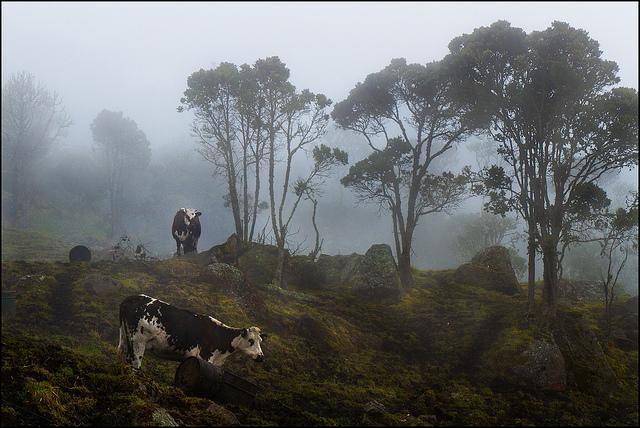Is this animal from Europe?
Be succinct. No. What sort of food are the cows eating?
Write a very short answer. Grass. What is the weather like?
Write a very short answer. Foggy. Are the animals in a compound?
Keep it brief. No. Is this a big city?
Concise answer only. No. Is it a cloudy day?
Short answer required. Yes. Is it a sunny day?
Give a very brief answer. No. What animal is in the photo?
Short answer required. Cow. Is the sun shining on the animals?
Answer briefly. No. What animal is this?
Quick response, please. Cow. Was this picture taken in the city?
Concise answer only. No. Why is it so dark outside?
Keep it brief. Fog. Is this a sheep and a cat?
Short answer required. No. What animals are shown in the photo?
Write a very short answer. Cows. Do these two like each other?
Write a very short answer. No. Where could you find this animal?
Keep it brief. Farm. Is there a calf with this cow?
Keep it brief. No. Are the animals wild?
Concise answer only. No. Are those brown spots?
Be succinct. Yes. Is it springtime?
Answer briefly. Yes. What is this animal?
Answer briefly. Cow. Are these animals in the wild?
Answer briefly. Yes. Is the sun shining?
Give a very brief answer. No. Is this a sunny day?
Quick response, please. No. Does the tree on the right seem to be barren of leaves?
Write a very short answer. No. Is the sun visible?
Be succinct. No. What type of animal is visible in the picture?
Be succinct. Cow. What environment is this?
Short answer required. Forest. What is the dog doing?
Concise answer only. Walking. How many trains do you see?
Give a very brief answer. 0. What animals are in the photograph?
Write a very short answer. Cows. What blurry animal is visible through the trees?
Answer briefly. Cow. What animal is in this picture?
Keep it brief. Cow. Is the cow indoors or outdoors in this picture?
Concise answer only. Outdoors. Are these animals contained?
Give a very brief answer. No. Is it foggy?
Answer briefly. Yes. Are these animals in a zoo?
Quick response, please. No. Is this a computerized image of two animals?
Answer briefly. No. Do trees have any foliage?
Concise answer only. Yes. What kind of animal is this?
Be succinct. Cow. Are the trees old?
Be succinct. Yes. 